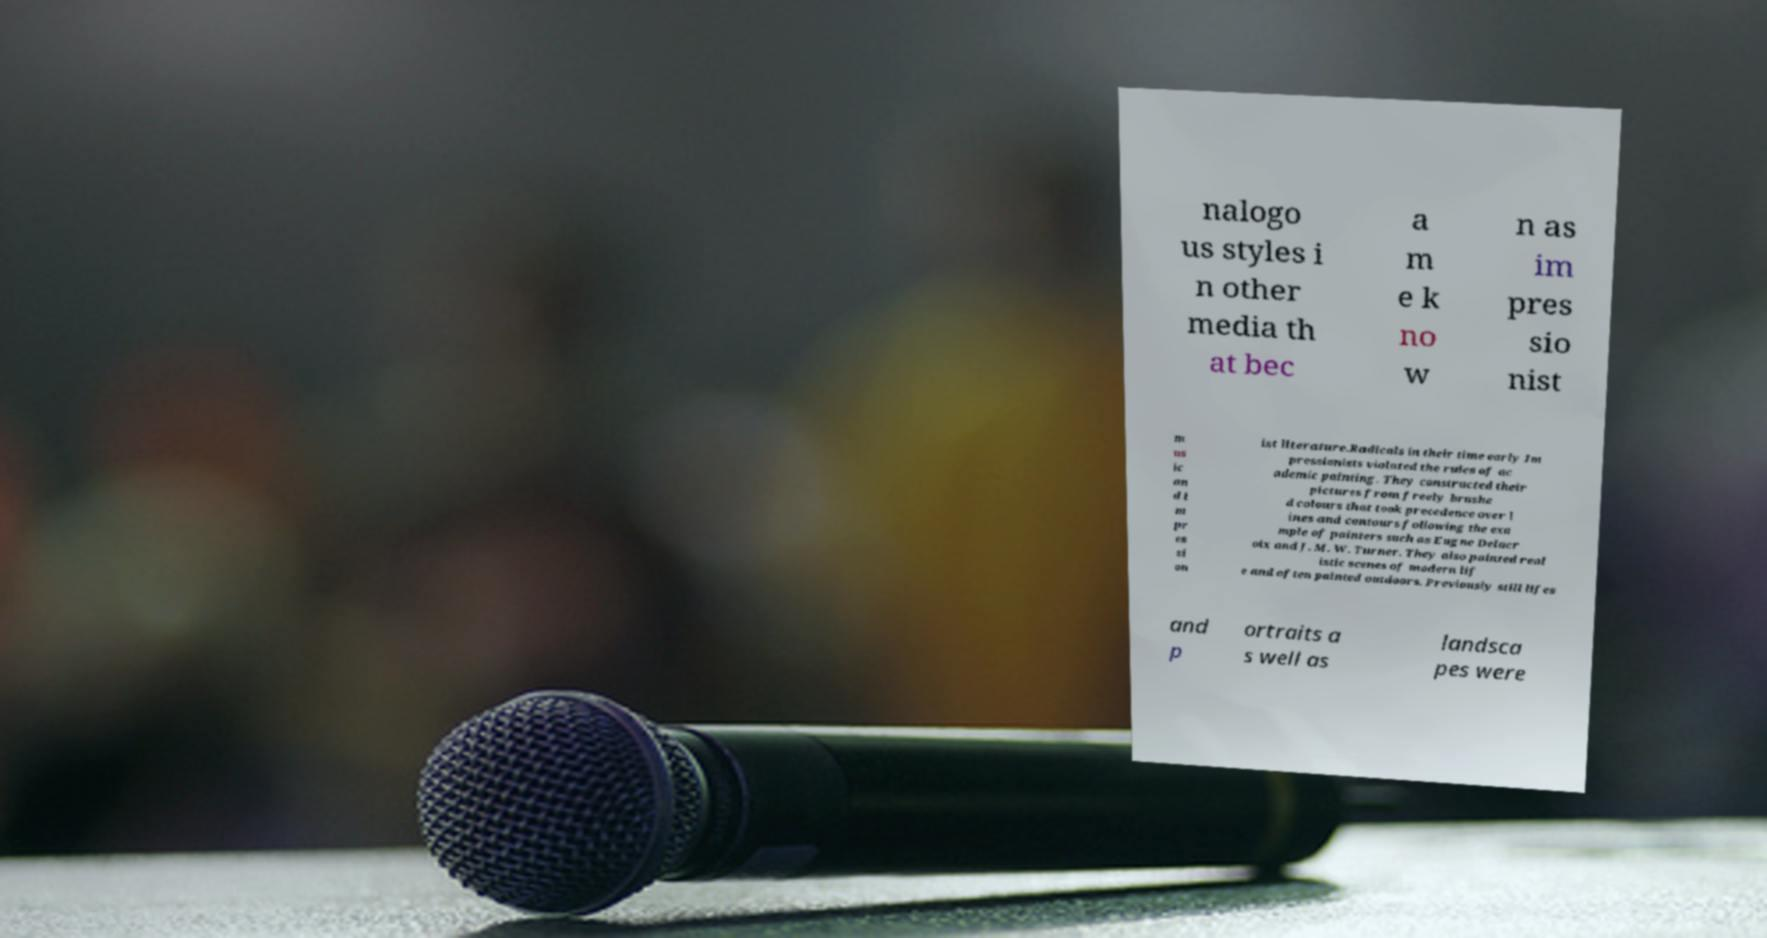For documentation purposes, I need the text within this image transcribed. Could you provide that? nalogo us styles i n other media th at bec a m e k no w n as im pres sio nist m us ic an d i m pr es si on ist literature.Radicals in their time early Im pressionists violated the rules of ac ademic painting. They constructed their pictures from freely brushe d colours that took precedence over l ines and contours following the exa mple of painters such as Eugne Delacr oix and J. M. W. Turner. They also painted real istic scenes of modern lif e and often painted outdoors. Previously still lifes and p ortraits a s well as landsca pes were 